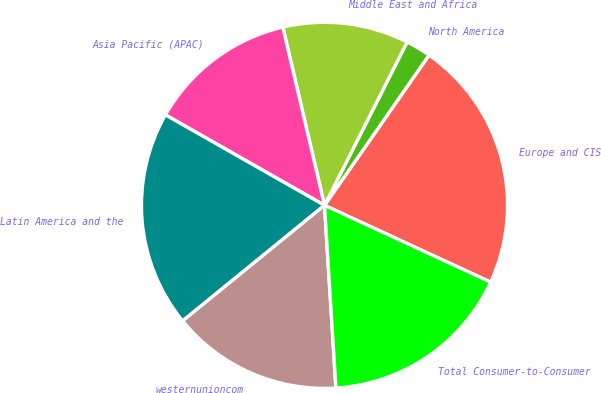<chart> <loc_0><loc_0><loc_500><loc_500><pie_chart><fcel>Europe and CIS<fcel>North America<fcel>Middle East and Africa<fcel>Asia Pacific (APAC)<fcel>Latin America and the<fcel>westernunioncom<fcel>Total Consumer-to-Consumer<nl><fcel>22.22%<fcel>2.22%<fcel>11.11%<fcel>13.11%<fcel>19.11%<fcel>15.11%<fcel>17.11%<nl></chart> 